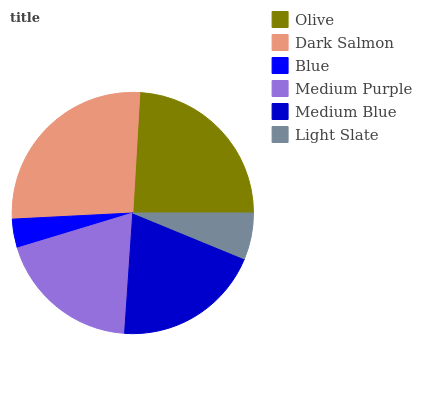Is Blue the minimum?
Answer yes or no. Yes. Is Dark Salmon the maximum?
Answer yes or no. Yes. Is Dark Salmon the minimum?
Answer yes or no. No. Is Blue the maximum?
Answer yes or no. No. Is Dark Salmon greater than Blue?
Answer yes or no. Yes. Is Blue less than Dark Salmon?
Answer yes or no. Yes. Is Blue greater than Dark Salmon?
Answer yes or no. No. Is Dark Salmon less than Blue?
Answer yes or no. No. Is Medium Blue the high median?
Answer yes or no. Yes. Is Medium Purple the low median?
Answer yes or no. Yes. Is Olive the high median?
Answer yes or no. No. Is Blue the low median?
Answer yes or no. No. 